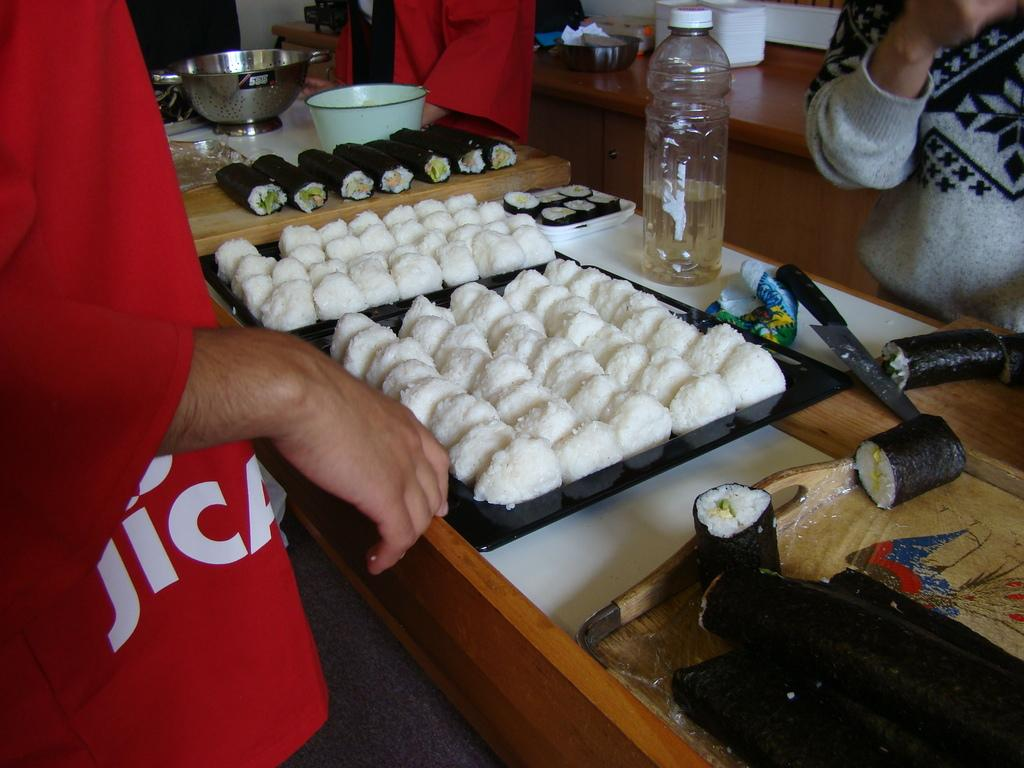What type of table is in the image? There is a wooden table in the image. What can be found on the wooden table? Delicious items and a water bottle are present on the table. What type of container is on the table? There is a bowl on the table. How many trails can be seen leading away from the table in the image? There are no trails visible in the image; it only shows a wooden table with items on it. 